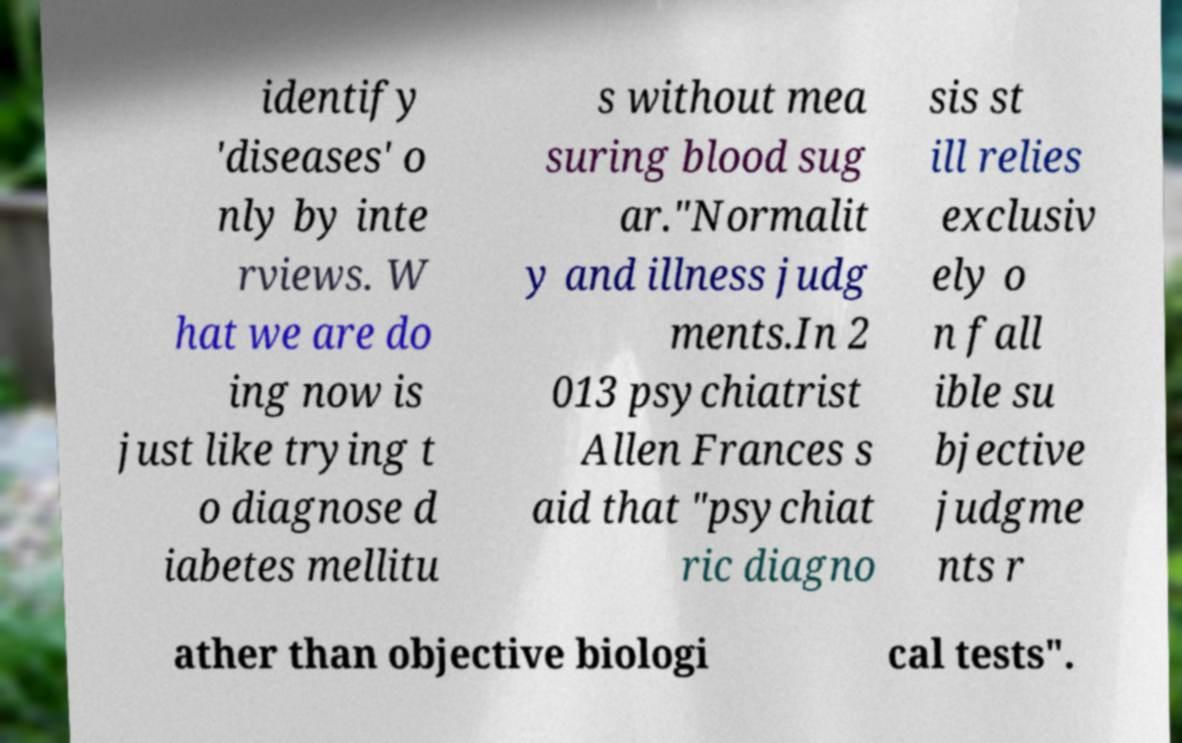Can you read and provide the text displayed in the image?This photo seems to have some interesting text. Can you extract and type it out for me? identify 'diseases' o nly by inte rviews. W hat we are do ing now is just like trying t o diagnose d iabetes mellitu s without mea suring blood sug ar."Normalit y and illness judg ments.In 2 013 psychiatrist Allen Frances s aid that "psychiat ric diagno sis st ill relies exclusiv ely o n fall ible su bjective judgme nts r ather than objective biologi cal tests". 